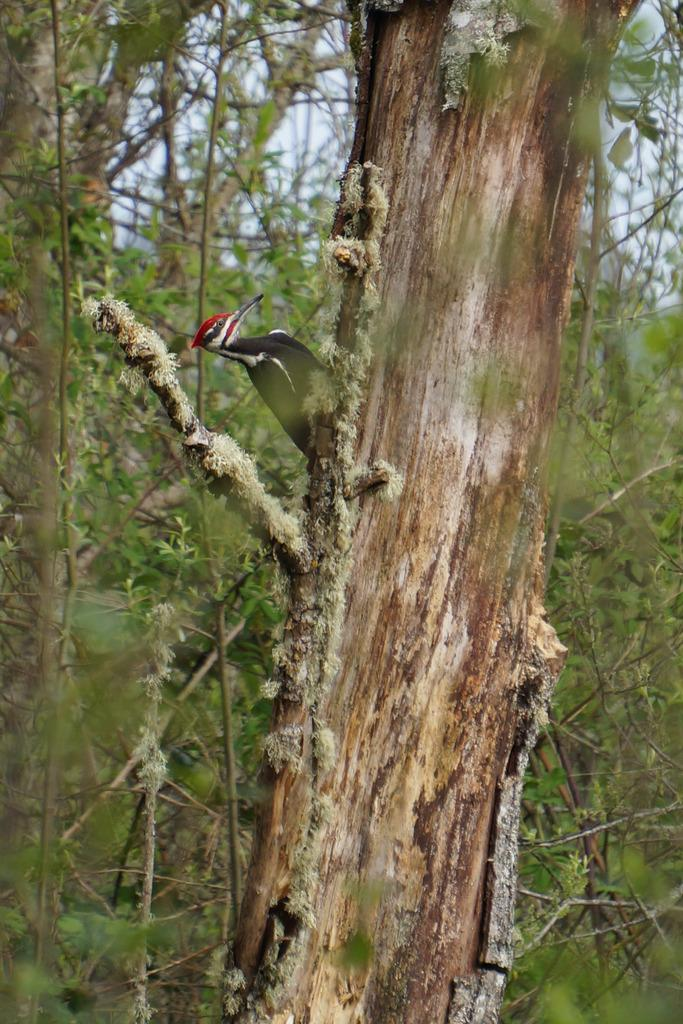What is the main subject in the foreground of the image? There is a tree in the picture, and a woodpecker is sitting on a branch of the tree. What can be seen in the background of the image? There are plenty of trees in the background of the image, and the sky is also visible. What type of shoe is the woodpecker wearing in the image? Woodpeckers do not wear shoes, and there is no shoe present in the image. 